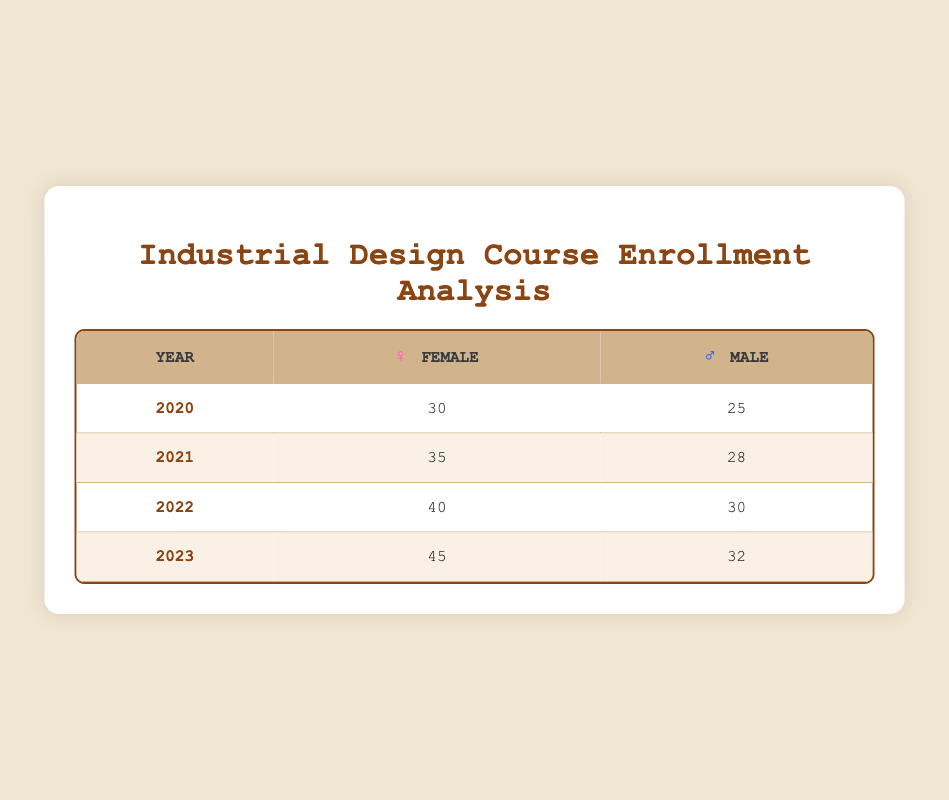What was the enrollment count for females in 2022? The enrollment count for females in 2022 is listed in the second column for the year 2022 in the table. The value is 40.
Answer: 40 What is the gender with the highest enrollment in 2021? We compare the values for both genders in 2021: Female has 35 and Male has 28. Since 35 is greater than 28, females had the highest enrollment.
Answer: Female What is the total enrollment for males from 2020 to 2023? To find the total, we sum the enrollment counts for males over the four years: 25 (2020) + 28 (2021) + 30 (2022) + 32 (2023) = 115.
Answer: 115 Did the enrollment for females increase every year? We check the enrollment counts for females across the years: 30 in 2020, 35 in 2021, 40 in 2022, and 45 in 2023. Each count is greater than the previous year, confirming an increase each time.
Answer: Yes What is the average enrollment count for males from 2020 to 2023? We sum the enrollment counts for males: 25 + 28 + 30 + 32 = 115. There are 4 years in total. We then calculate the average: 115 / 4 = 28.75.
Answer: 28.75 How many more females enrolled compared to males in 2023? For 2023, the female enrollment is 45 and the male enrollment is 32. We subtract the male count from the female count: 45 - 32 = 13.
Answer: 13 In which year did males have the lowest enrollment? By examining the counts, we see that males had 25 in 2020, which is lower than 28 in 2021, 30 in 2022, and 32 in 2023. Thus, 2020 is the year with the lowest enrollment for males.
Answer: 2020 What is the difference in enrollment counts between the genders in 2022? For 2022, the enrollment count for females is 40 and for males is 30. We subtract the male count from the female count: 40 - 30 = 10.
Answer: 10 